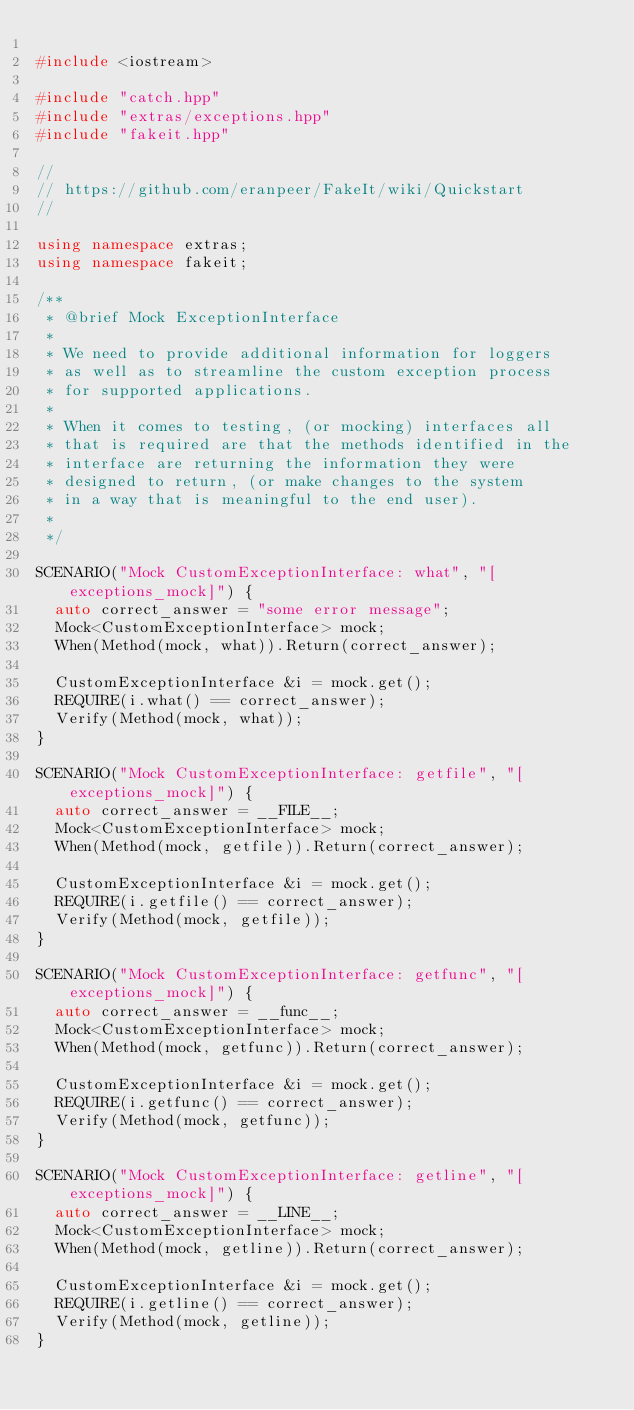Convert code to text. <code><loc_0><loc_0><loc_500><loc_500><_C++_>
#include <iostream>

#include "catch.hpp"
#include "extras/exceptions.hpp"
#include "fakeit.hpp"

//
// https://github.com/eranpeer/FakeIt/wiki/Quickstart
//

using namespace extras;
using namespace fakeit;

/**
 * @brief Mock ExceptionInterface
 *
 * We need to provide additional information for loggers
 * as well as to streamline the custom exception process
 * for supported applications.
 *
 * When it comes to testing, (or mocking) interfaces all
 * that is required are that the methods identified in the
 * interface are returning the information they were
 * designed to return, (or make changes to the system
 * in a way that is meaningful to the end user).
 *
 */

SCENARIO("Mock CustomExceptionInterface: what", "[exceptions_mock]") {
  auto correct_answer = "some error message";
  Mock<CustomExceptionInterface> mock;
  When(Method(mock, what)).Return(correct_answer);

  CustomExceptionInterface &i = mock.get();
  REQUIRE(i.what() == correct_answer);
  Verify(Method(mock, what));
}

SCENARIO("Mock CustomExceptionInterface: getfile", "[exceptions_mock]") {
  auto correct_answer = __FILE__;
  Mock<CustomExceptionInterface> mock;
  When(Method(mock, getfile)).Return(correct_answer);

  CustomExceptionInterface &i = mock.get();
  REQUIRE(i.getfile() == correct_answer);
  Verify(Method(mock, getfile));
}

SCENARIO("Mock CustomExceptionInterface: getfunc", "[exceptions_mock]") {
  auto correct_answer = __func__;
  Mock<CustomExceptionInterface> mock;
  When(Method(mock, getfunc)).Return(correct_answer);

  CustomExceptionInterface &i = mock.get();
  REQUIRE(i.getfunc() == correct_answer);
  Verify(Method(mock, getfunc));
}

SCENARIO("Mock CustomExceptionInterface: getline", "[exceptions_mock]") {
  auto correct_answer = __LINE__;
  Mock<CustomExceptionInterface> mock;
  When(Method(mock, getline)).Return(correct_answer);

  CustomExceptionInterface &i = mock.get();
  REQUIRE(i.getline() == correct_answer);
  Verify(Method(mock, getline));
}
</code> 